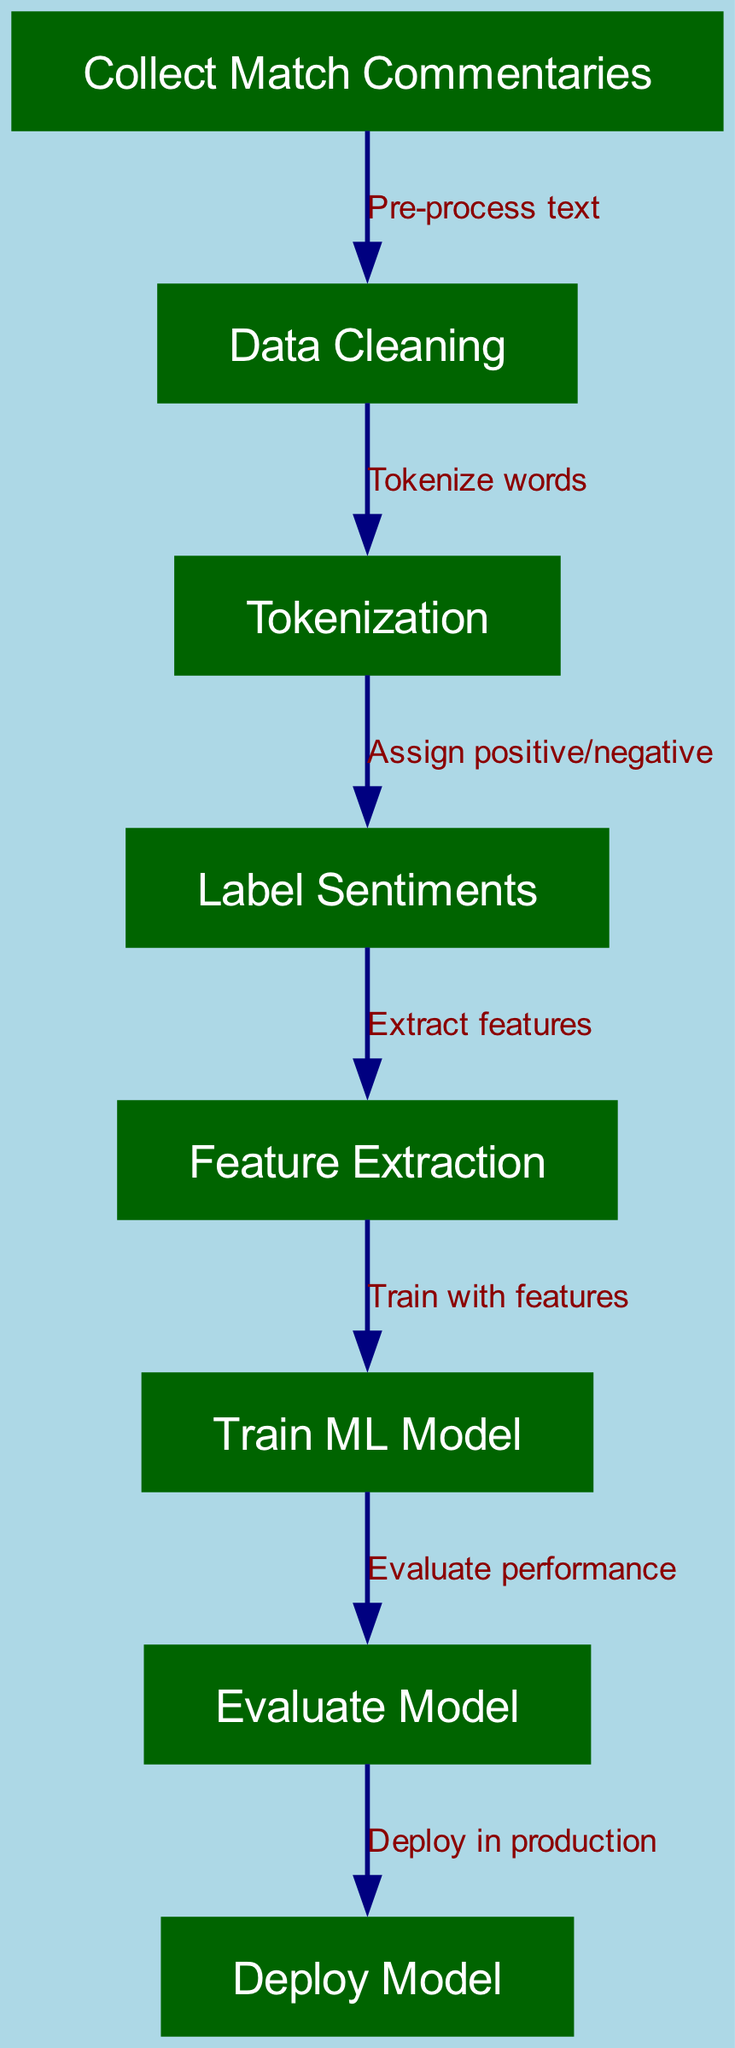What is the first step in the machine learning pipeline? The first step listed in the diagram is "Collect Match Commentaries," which is represented as the starting node of the flow. It initiates the process of gathering data for analysis.
Answer: Collect Match Commentaries How many nodes are present in the diagram? By counting each item under the "nodes" category in the provided data, there are a total of eight nodes that represent different stages of the sentiment analysis process.
Answer: 8 What does the "Data Cleaning" node lead to? According to the diagram, "Data Cleaning" connects to "Tokenization," indicating that after cleaning the data, the next step involves breaking the text into individual tokens or words.
Answer: Tokenization What sentiment labels can be assigned during sentiment labeling? The diagram clearly states that during the "Sentiment Labeling" step, the sentiments assigned are either positive or negative, which are common sentiment categories in analysis.
Answer: Positive/Negative What connects "Training Model" to "Evaluate Model"? The relationship shown in the diagram indicates that the "Evaluate Model" node follows directly after the "Train ML Model" node, signifying that model performance must be evaluated after training.
Answer: Evaluate Model Which node is responsible for extracting features? The node labeled "Feature Extraction" is the stage responsible for extracting features from the data after sentiments have been labeled, making it a crucial step in preparing for model training.
Answer: Feature Extraction What action takes place after model evaluation? After "Evaluate Model," the next step in the process is "Deploy Model," indicating that once evaluation is complete, the model can be put into production for practical use.
Answer: Deploy Model What is the relationship between "Tokenization" and "Sentiment Labeling"? The diagram illustrates that "Tokenization" leads to "Sentiment Labeling," meaning that once the words are tokenized, the next step is to assign sentiment to those tokens.
Answer: Assign positive/negative What type of diagram is used in this data representation? The type of diagram represented in this data is a "Machine Learning Diagram," specifically focusing on the process of sentiment analysis for tennis match commentaries.
Answer: Machine Learning Diagram 